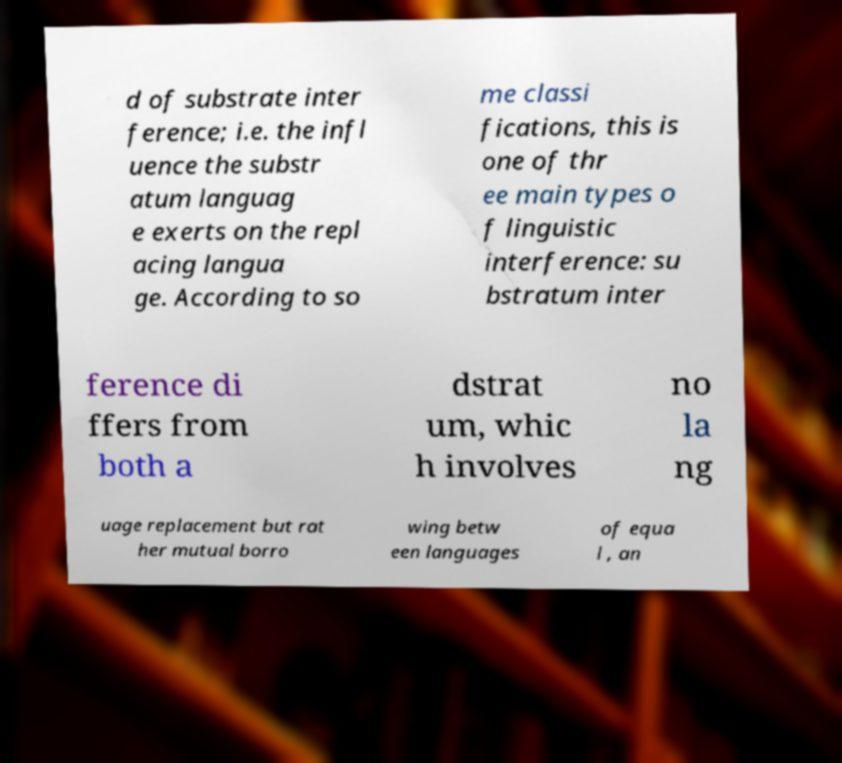Could you assist in decoding the text presented in this image and type it out clearly? d of substrate inter ference; i.e. the infl uence the substr atum languag e exerts on the repl acing langua ge. According to so me classi fications, this is one of thr ee main types o f linguistic interference: su bstratum inter ference di ffers from both a dstrat um, whic h involves no la ng uage replacement but rat her mutual borro wing betw een languages of equa l , an 